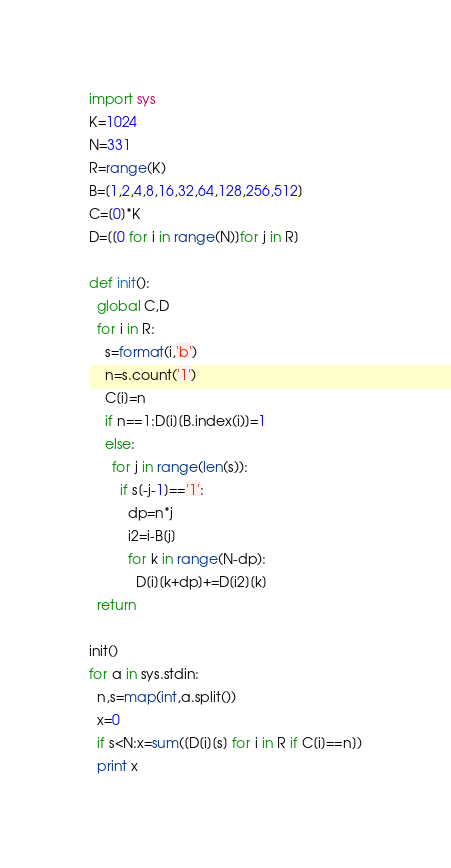<code> <loc_0><loc_0><loc_500><loc_500><_Python_>import sys
K=1024
N=331
R=range(K)
B=[1,2,4,8,16,32,64,128,256,512]
C=[0]*K
D=[[0 for i in range(N)]for j in R]

def init():
  global C,D
  for i in R:
    s=format(i,'b')
    n=s.count('1')
    C[i]=n
    if n==1:D[i][B.index(i)]=1
    else:
      for j in range(len(s)):
        if s[-j-1]=='1':
          dp=n*j
          i2=i-B[j]
          for k in range(N-dp):
            D[i][k+dp]+=D[i2][k]
  return
   
init()
for a in sys.stdin:
  n,s=map(int,a.split())
  x=0
  if s<N:x=sum([D[i][s] for i in R if C[i]==n])
  print x</code> 